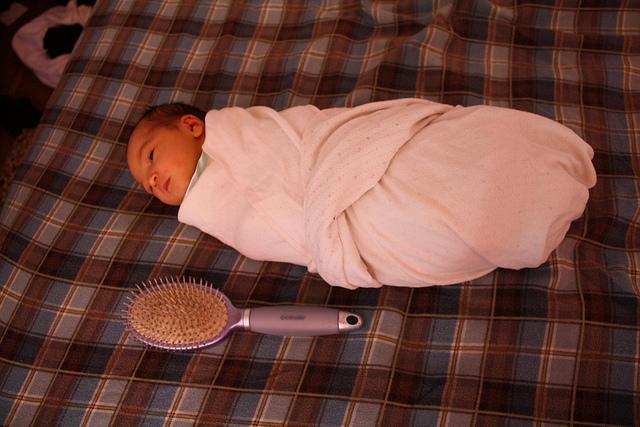What is the baby wrapped in?
Answer briefly. Blanket. Why is the hairbrush next to the baby?
Write a very short answer. Accident. What is the baby sleeping on?
Answer briefly. Blanket. 